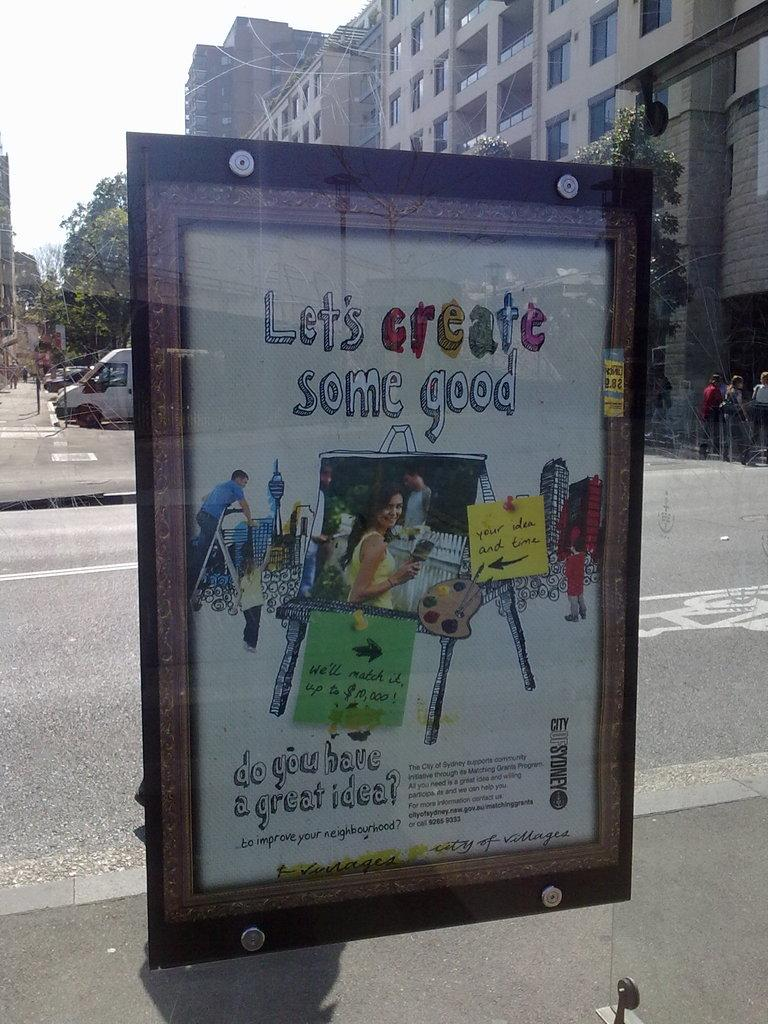<image>
Describe the image concisely. An outdoor advertisement encourages people to create some good. 